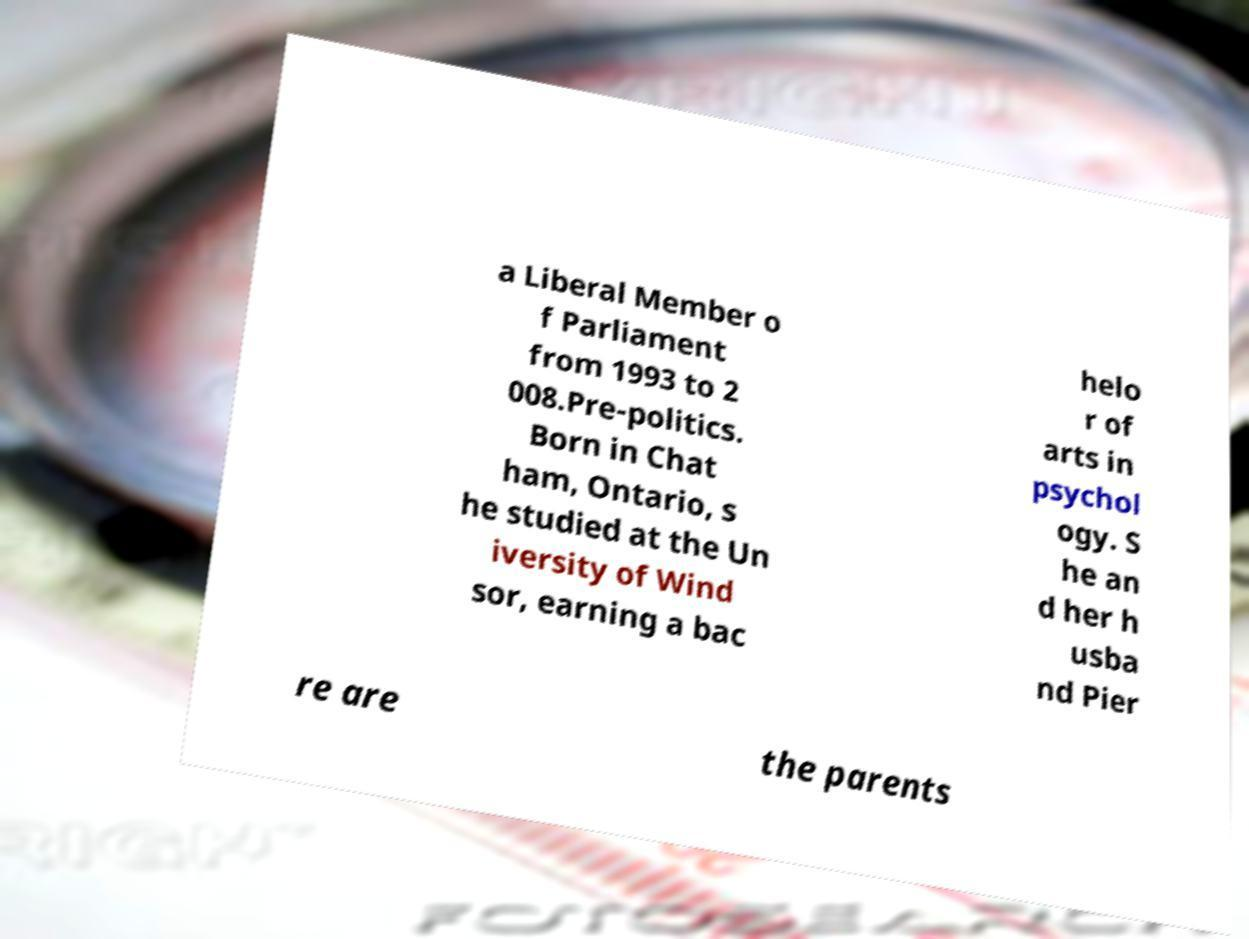Please identify and transcribe the text found in this image. a Liberal Member o f Parliament from 1993 to 2 008.Pre-politics. Born in Chat ham, Ontario, s he studied at the Un iversity of Wind sor, earning a bac helo r of arts in psychol ogy. S he an d her h usba nd Pier re are the parents 